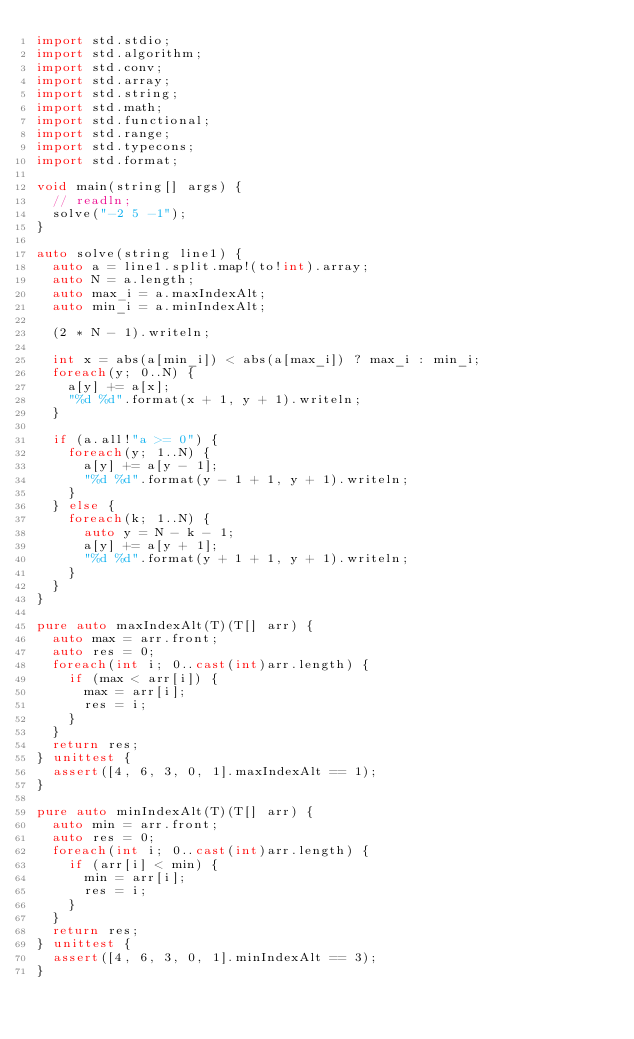<code> <loc_0><loc_0><loc_500><loc_500><_D_>import std.stdio;
import std.algorithm;
import std.conv;
import std.array;
import std.string;
import std.math;
import std.functional;
import std.range;
import std.typecons;
import std.format;

void main(string[] args) {
  // readln;
  solve("-2 5 -1");
}

auto solve(string line1) {
  auto a = line1.split.map!(to!int).array;
  auto N = a.length;
  auto max_i = a.maxIndexAlt;
  auto min_i = a.minIndexAlt;
  
  (2 * N - 1).writeln;
  
  int x = abs(a[min_i]) < abs(a[max_i]) ? max_i : min_i;
  foreach(y; 0..N) {
    a[y] += a[x];
    "%d %d".format(x + 1, y + 1).writeln;
  }

  if (a.all!"a >= 0") {
    foreach(y; 1..N) {
      a[y] += a[y - 1];
      "%d %d".format(y - 1 + 1, y + 1).writeln;
    }
  } else {
    foreach(k; 1..N) {
      auto y = N - k - 1;
      a[y] += a[y + 1];
      "%d %d".format(y + 1 + 1, y + 1).writeln;
    }
  }
}

pure auto maxIndexAlt(T)(T[] arr) {
  auto max = arr.front;
  auto res = 0;
  foreach(int i; 0..cast(int)arr.length) {
    if (max < arr[i]) {
      max = arr[i];
      res = i;
    }
  }
  return res;
} unittest {
  assert([4, 6, 3, 0, 1].maxIndexAlt == 1);
}

pure auto minIndexAlt(T)(T[] arr) {
  auto min = arr.front;
  auto res = 0;
  foreach(int i; 0..cast(int)arr.length) {
    if (arr[i] < min) {
      min = arr[i];
      res = i;
    }
  }
  return res;
} unittest {
  assert([4, 6, 3, 0, 1].minIndexAlt == 3);
}
</code> 